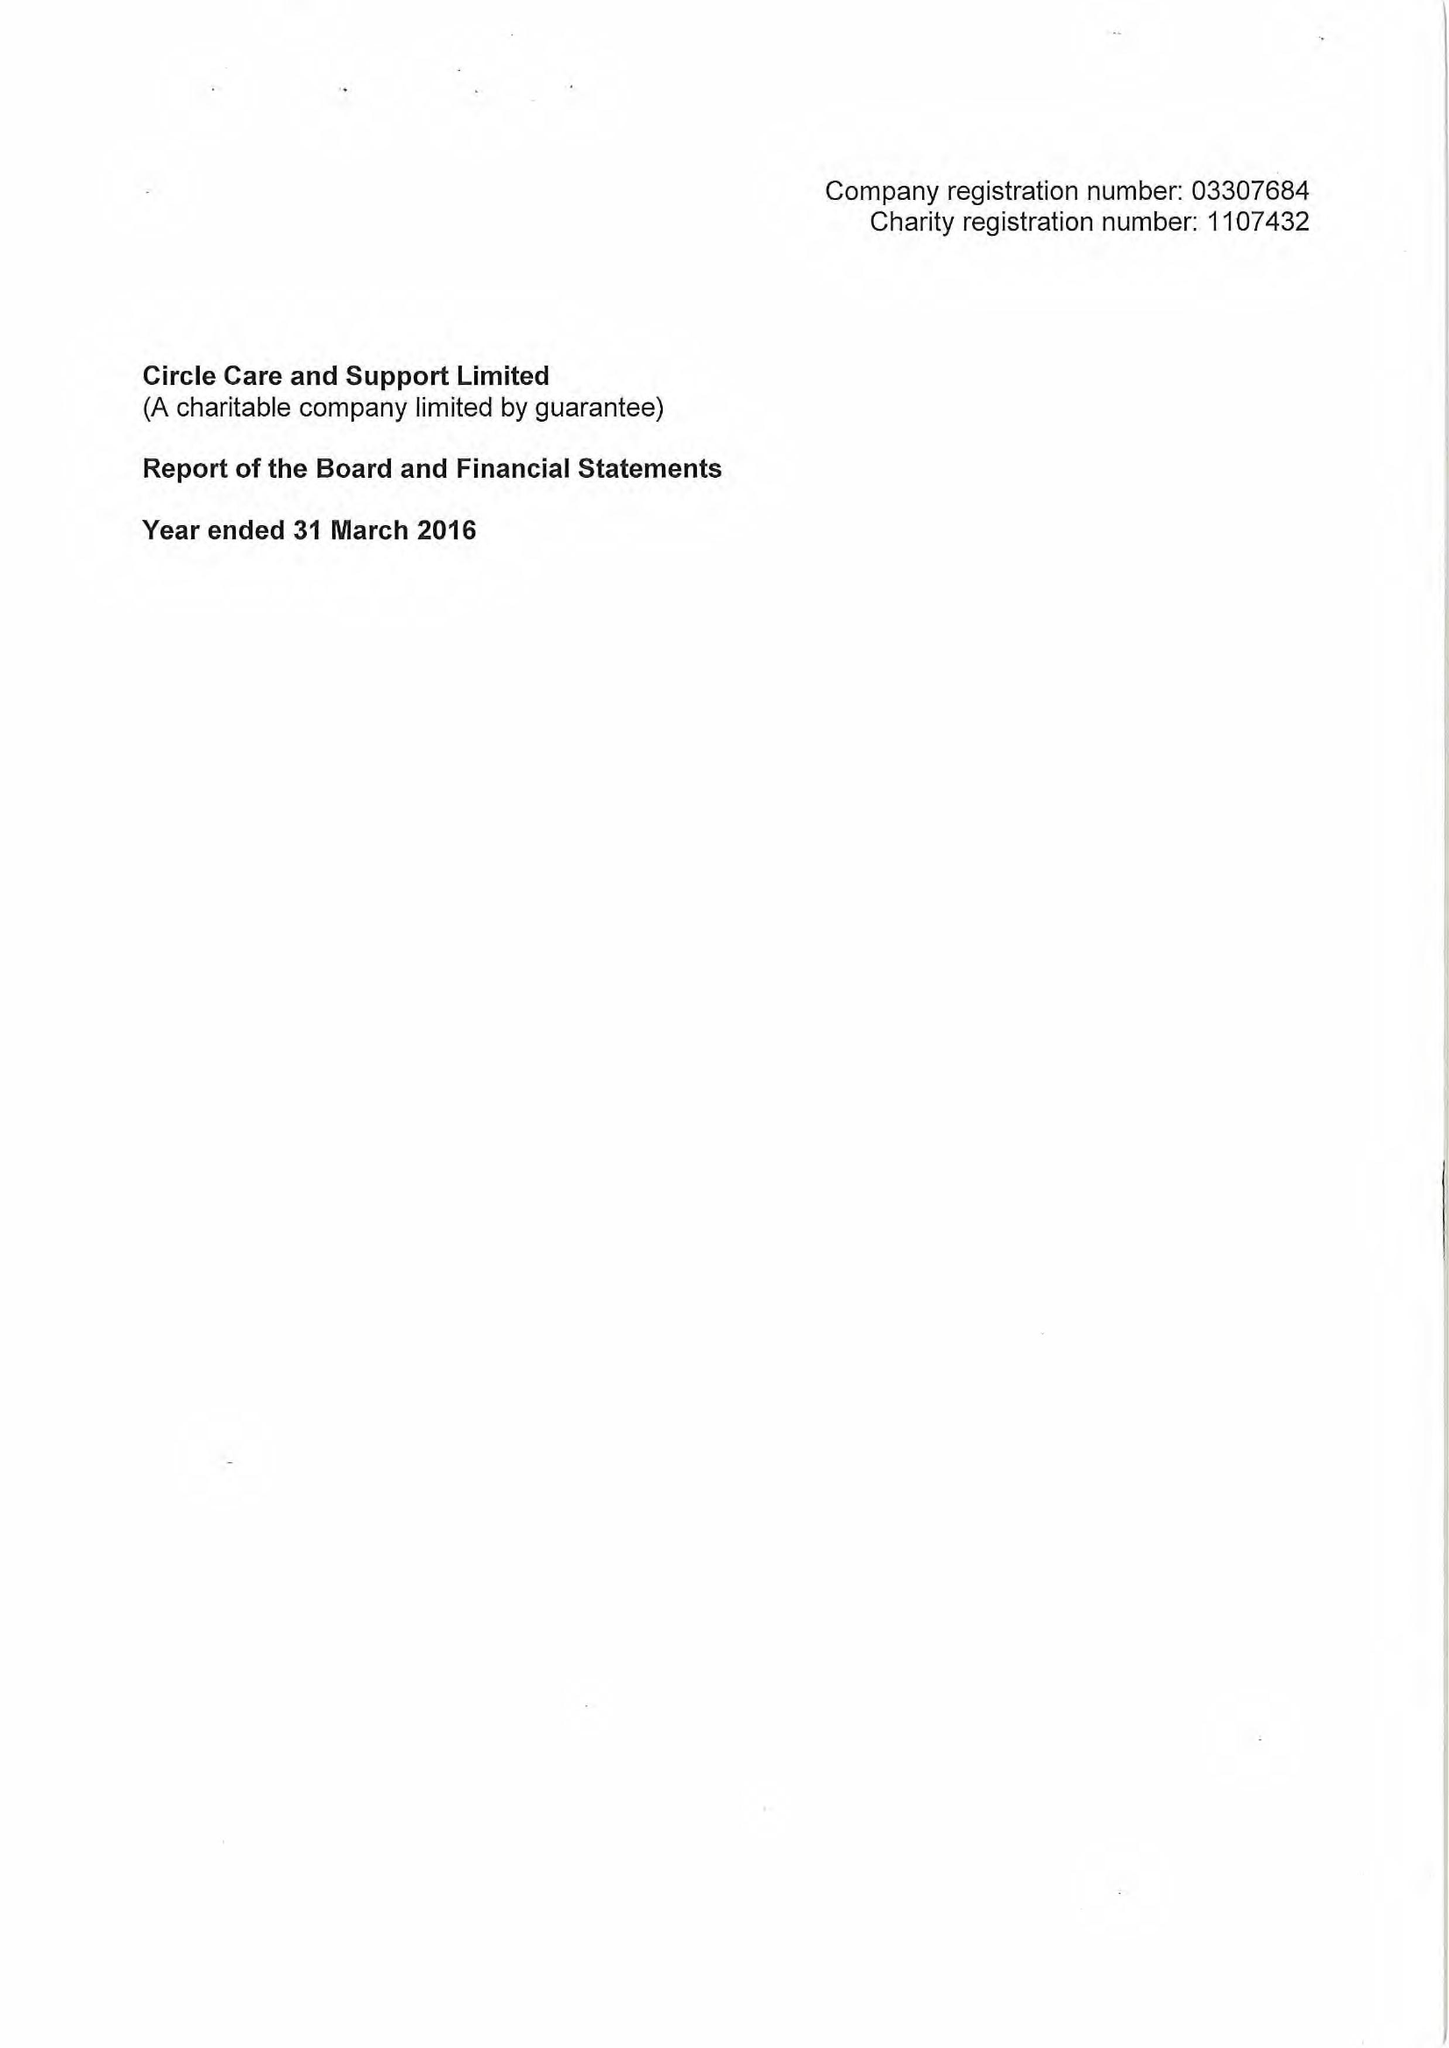What is the value for the income_annually_in_british_pounds?
Answer the question using a single word or phrase. 16323000.00 